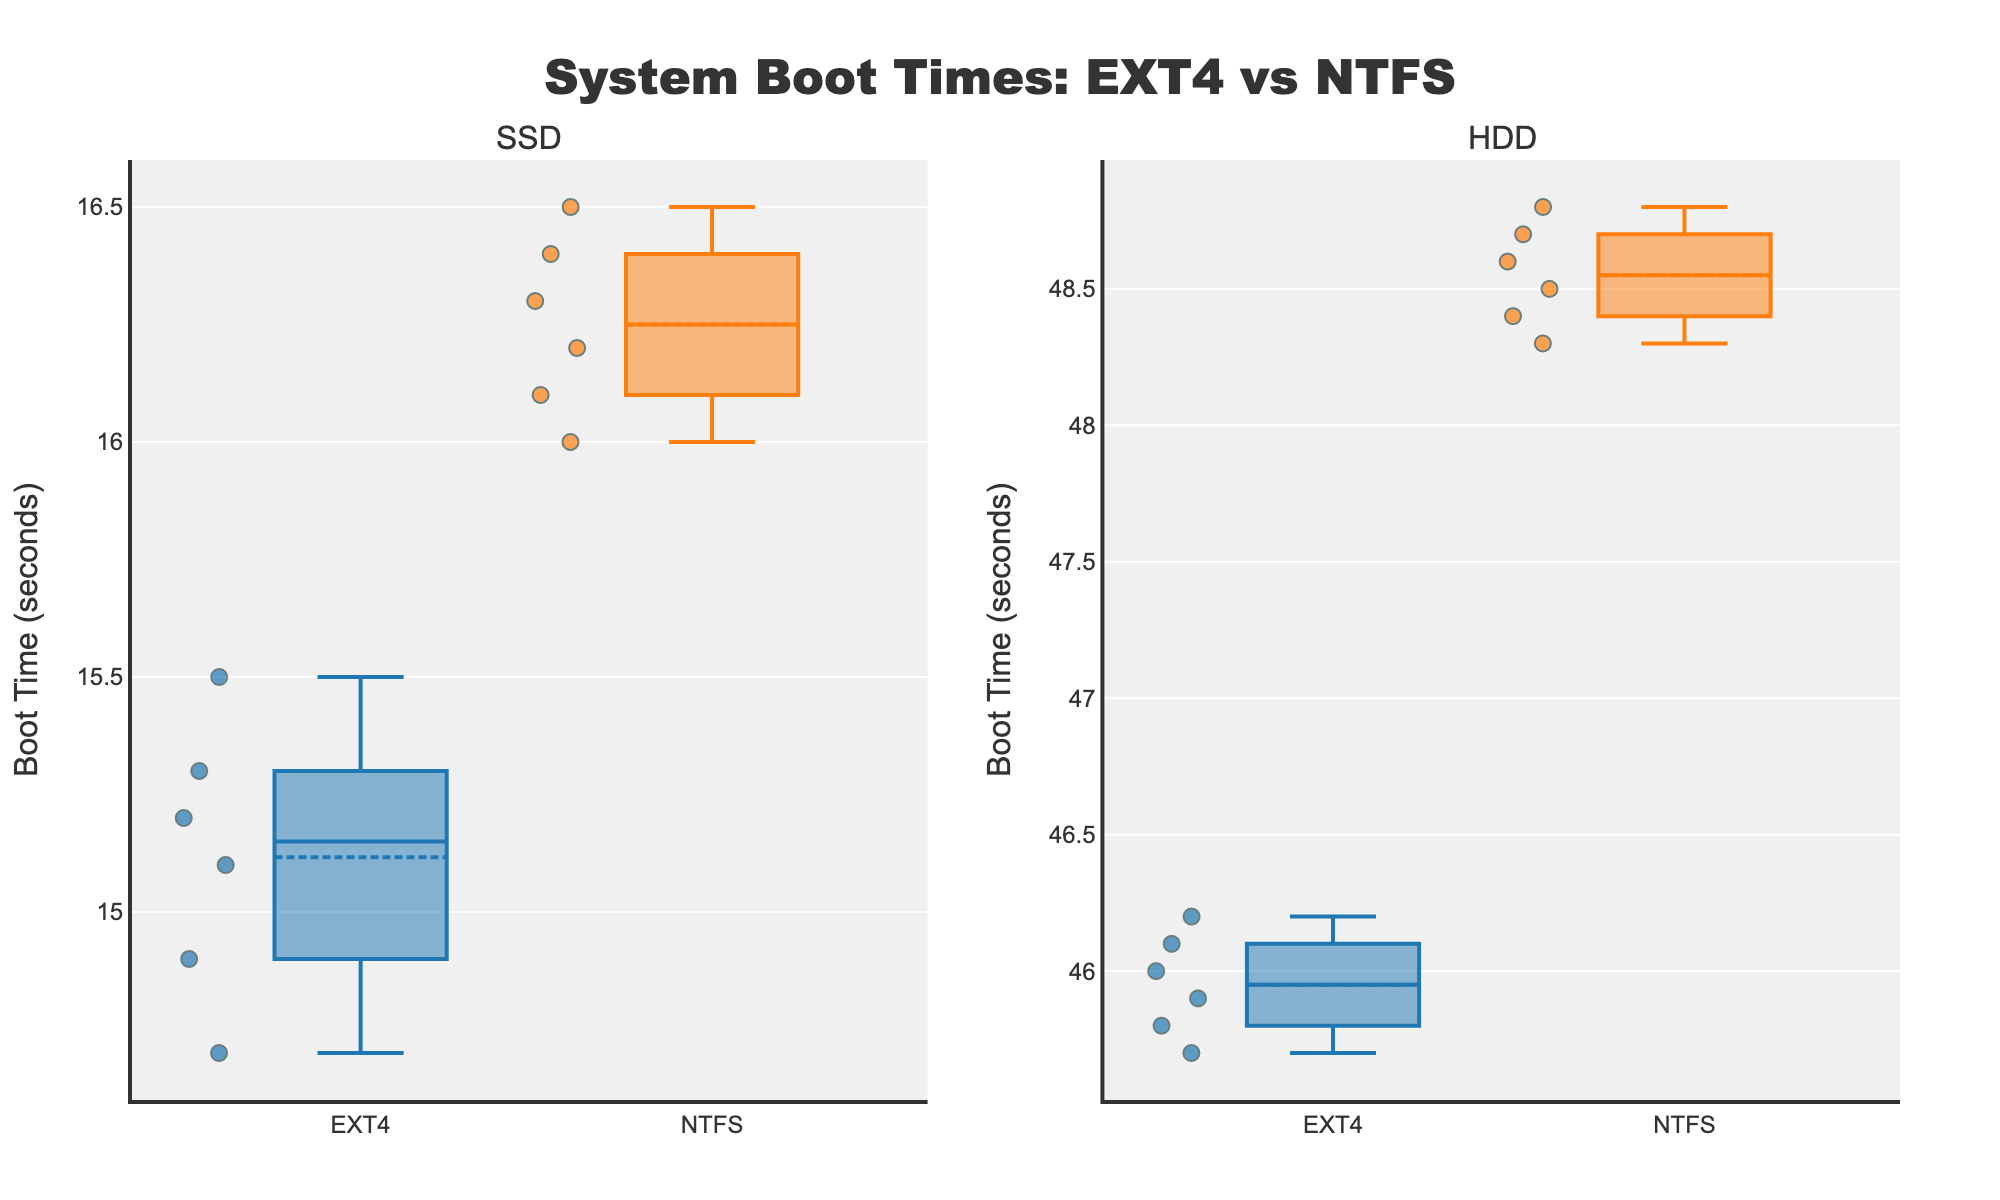What is the title of the plot? The title text is found at the top of the plot and summarizes the content. The title is "System Boot Times: EXT4 vs NTFS".
Answer: System Boot Times: EXT4 vs NTFS What does the y-axis represent? The y-axis title is shown at the left side of the plot and provides information about the measurement being displayed. The y-axis represents "Boot Time (seconds)".
Answer: Boot Time (seconds) Which storage type has the higher median boot time when using the NTFS file system? Looking at the box plots for NTFS, compare the median lines (central lines within the boxes) for SSD and HDD. The HDD has a higher median line than the SSD.
Answer: HDD Which file system shows a larger spread of boot times on SSDs? Examine the width of the boxes and the range of whiskers for EXT4 and NTFS on the SSD subplot to determine which has a wider distribution. NTFS shows a larger spread than EXT4 on SSDs.
Answer: NTFS How many data points are there for the EXT4 file system on HDD? Count the individual data points (dots within the box) in the EXT4 box plot for HDD. There are six data points.
Answer: 6 What is the interquartile range (IQR) for the EXT4 file system on HDD? The IQR is the range covered by the box's length (between the 25th and 75th percentiles). Examine the lower and upper edges of the box for EXT4 on HDD. The IQR is from approximately 45.7 to 46.1. Calculating the difference, the IQR is 46.1 - 45.7 = 0.4.
Answer: 0.4 Which file system has a higher average boot time on SSDs, EXT4 or NTFS? The average is indicated by the small diamond/marker within the box. Compare the average markers for EXT4 and NTFS on SSD. NTFS has the higher average boot time.
Answer: NTFS What is the difference in median boot time when comparing EXT4 on SSDs and HDDs? Compare the median lines for EXT4 between SSD and HDD subplots. The median on SSD is approximately 15.2, and on HDD, it is about 46.0. The difference is 46.0 - 15.2 = 30.8 seconds.
Answer: 30.8 seconds Which storage type shows a smaller variation in boot times using the NTFS file system? Compare the height of the boxes and the lengths of the whiskers for NTFS between SSD and HDD plots. The SSD shows a smaller variation in boot times than the HDD.
Answer: SSD 